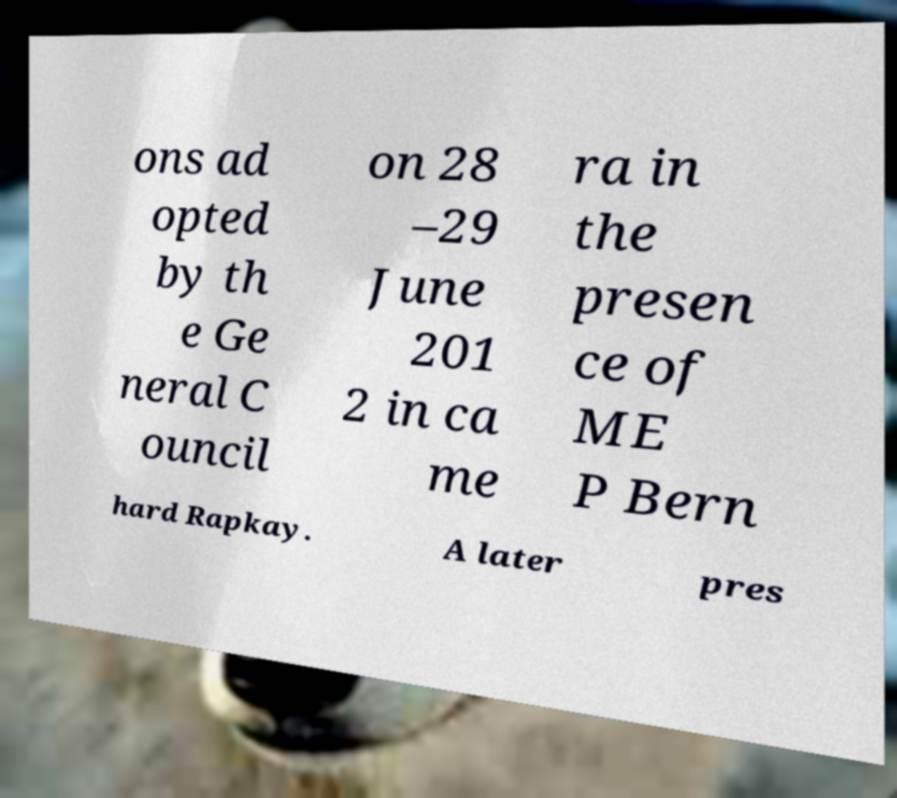Could you assist in decoding the text presented in this image and type it out clearly? ons ad opted by th e Ge neral C ouncil on 28 –29 June 201 2 in ca me ra in the presen ce of ME P Bern hard Rapkay. A later pres 